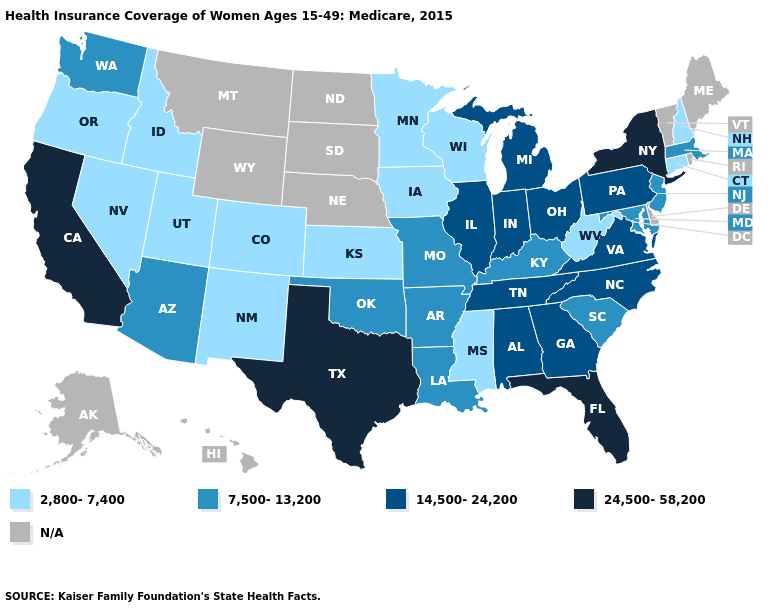Name the states that have a value in the range 24,500-58,200?
Be succinct. California, Florida, New York, Texas. How many symbols are there in the legend?
Answer briefly. 5. Which states have the lowest value in the USA?
Be succinct. Colorado, Connecticut, Idaho, Iowa, Kansas, Minnesota, Mississippi, Nevada, New Hampshire, New Mexico, Oregon, Utah, West Virginia, Wisconsin. What is the value of New Hampshire?
Quick response, please. 2,800-7,400. Does West Virginia have the lowest value in the South?
Give a very brief answer. Yes. Which states have the lowest value in the Northeast?
Be succinct. Connecticut, New Hampshire. Which states have the lowest value in the USA?
Short answer required. Colorado, Connecticut, Idaho, Iowa, Kansas, Minnesota, Mississippi, Nevada, New Hampshire, New Mexico, Oregon, Utah, West Virginia, Wisconsin. Does the map have missing data?
Short answer required. Yes. Is the legend a continuous bar?
Keep it brief. No. Name the states that have a value in the range 14,500-24,200?
Concise answer only. Alabama, Georgia, Illinois, Indiana, Michigan, North Carolina, Ohio, Pennsylvania, Tennessee, Virginia. Does Florida have the highest value in the USA?
Short answer required. Yes. What is the lowest value in the West?
Short answer required. 2,800-7,400. Which states have the lowest value in the USA?
Concise answer only. Colorado, Connecticut, Idaho, Iowa, Kansas, Minnesota, Mississippi, Nevada, New Hampshire, New Mexico, Oregon, Utah, West Virginia, Wisconsin. Name the states that have a value in the range N/A?
Give a very brief answer. Alaska, Delaware, Hawaii, Maine, Montana, Nebraska, North Dakota, Rhode Island, South Dakota, Vermont, Wyoming. 